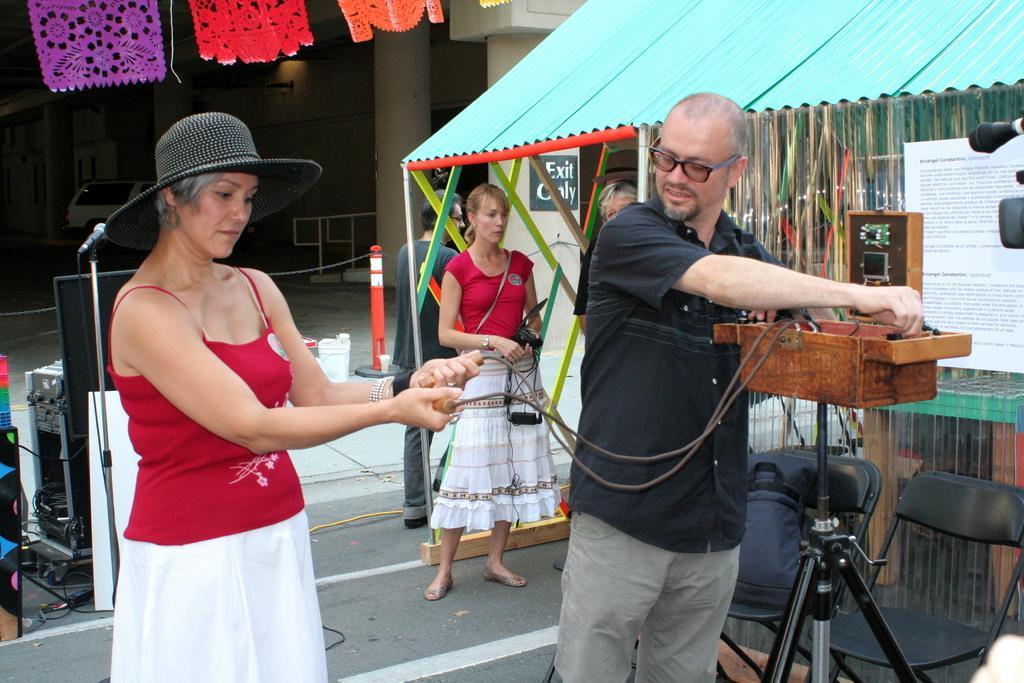Describe this image in one or two sentences. In this image, we can see a man and a woman standing, in the background there are some people standing, we can see a shed. 